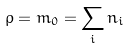<formula> <loc_0><loc_0><loc_500><loc_500>\rho = m _ { 0 } = \sum _ { i } n _ { i }</formula> 